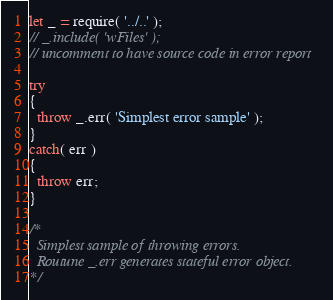<code> <loc_0><loc_0><loc_500><loc_500><_JavaScript_>let _ = require( '../..' );
// _.include( 'wFiles' );
// uncomment to have source code in error report

try
{
  throw _.err( 'Simplest error sample' );
}
catch( err )
{
  throw err;
}

/*
  Simplest sample of throwing errors.
  Routune _.err generates stateful error object.
*/
</code> 